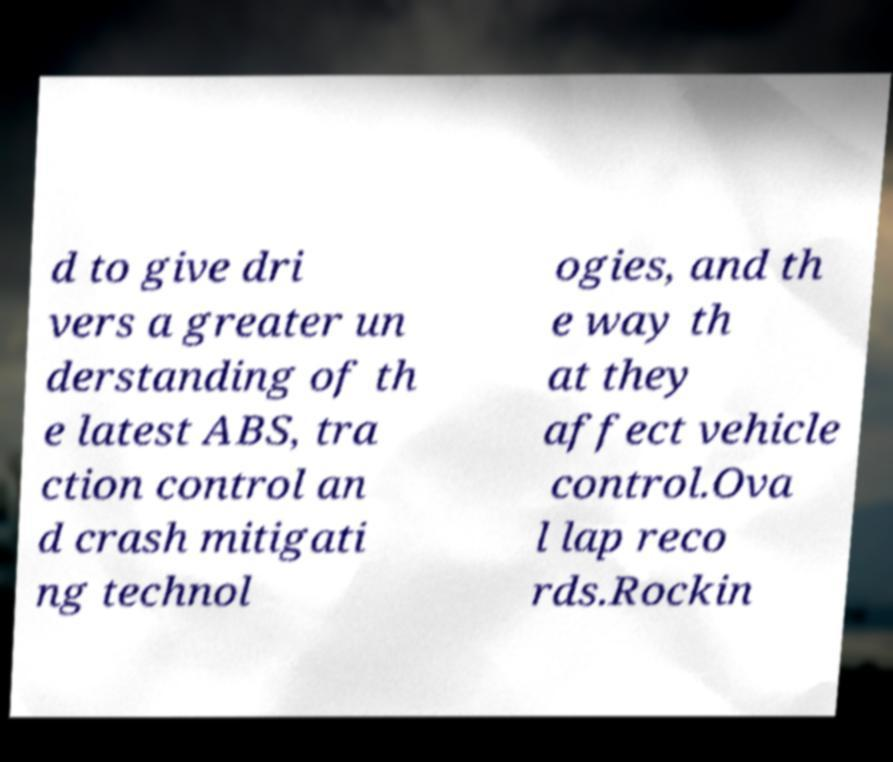Please read and relay the text visible in this image. What does it say? d to give dri vers a greater un derstanding of th e latest ABS, tra ction control an d crash mitigati ng technol ogies, and th e way th at they affect vehicle control.Ova l lap reco rds.Rockin 